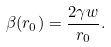Convert formula to latex. <formula><loc_0><loc_0><loc_500><loc_500>\beta ( r _ { 0 } ) = \frac { 2 \gamma w } { r _ { 0 } } .</formula> 